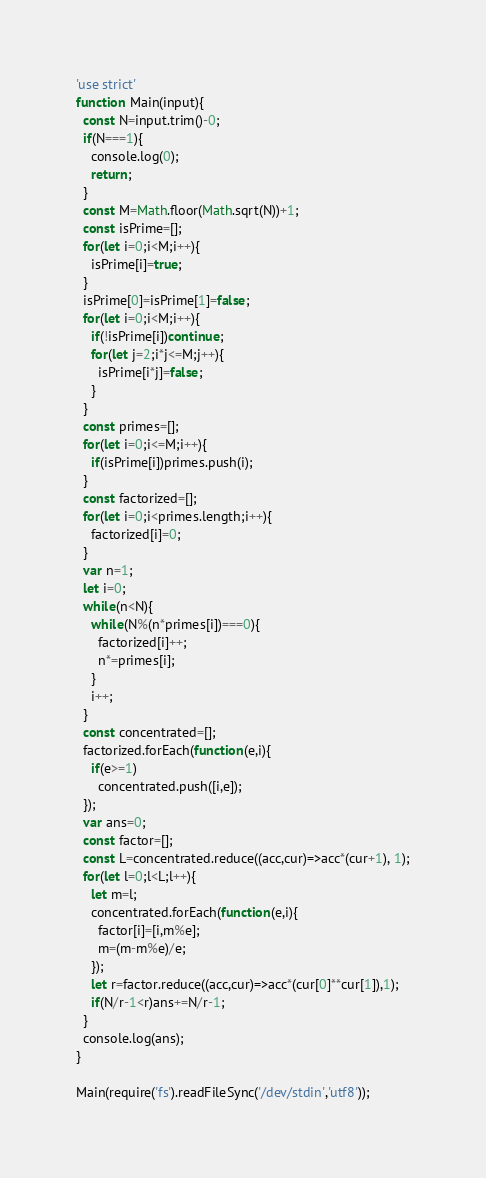<code> <loc_0><loc_0><loc_500><loc_500><_JavaScript_>'use strict'
function Main(input){
  const N=input.trim()-0;
  if(N===1){
    console.log(0);
    return;
  }
  const M=Math.floor(Math.sqrt(N))+1;
  const isPrime=[];
  for(let i=0;i<M;i++){
    isPrime[i]=true;
  }
  isPrime[0]=isPrime[1]=false;
  for(let i=0;i<M;i++){
    if(!isPrime[i])continue;
    for(let j=2;i*j<=M;j++){
      isPrime[i*j]=false;
    }
  }
  const primes=[];
  for(let i=0;i<=M;i++){
    if(isPrime[i])primes.push(i);
  }
  const factorized=[];
  for(let i=0;i<primes.length;i++){
    factorized[i]=0;
  }
  var n=1;
  let i=0;
  while(n<N){
    while(N%(n*primes[i])===0){
      factorized[i]++;
      n*=primes[i];
    }
    i++;
  }
  const concentrated=[];
  factorized.forEach(function(e,i){
    if(e>=1)
      concentrated.push([i,e]);
  });
  var ans=0;
  const factor=[];
  const L=concentrated.reduce((acc,cur)=>acc*(cur+1), 1);
  for(let l=0;l<L;l++){
    let m=l;
    concentrated.forEach(function(e,i){
      factor[i]=[i,m%e];
      m=(m-m%e)/e;
    });
    let r=factor.reduce((acc,cur)=>acc*(cur[0]**cur[1]),1);
    if(N/r-1<r)ans+=N/r-1;
  }
  console.log(ans);
}

Main(require('fs').readFileSync('/dev/stdin','utf8'));</code> 